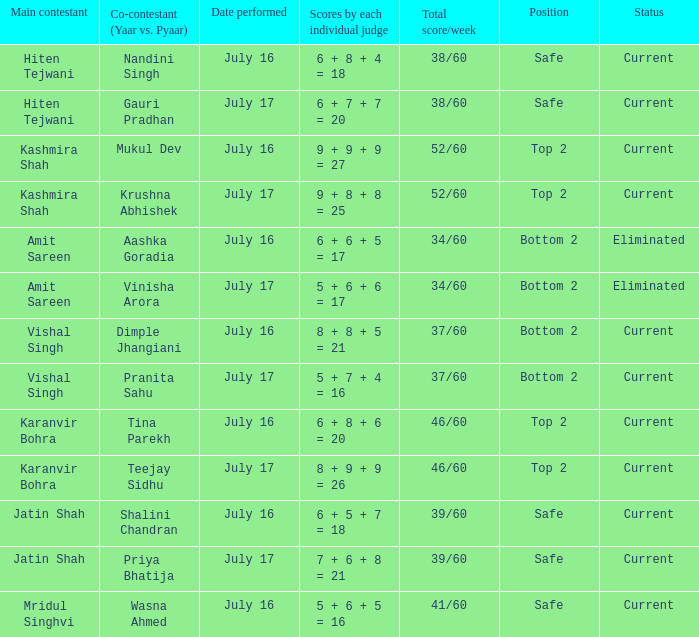What position did the team with the total score of 41/60 get? Safe. 